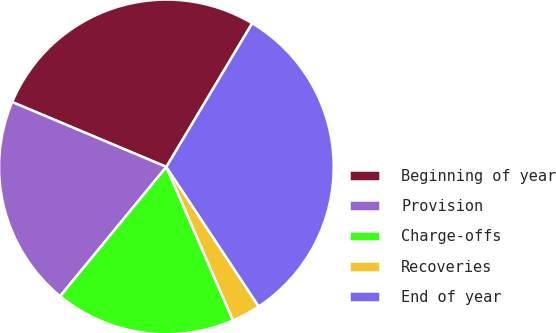Convert chart to OTSL. <chart><loc_0><loc_0><loc_500><loc_500><pie_chart><fcel>Beginning of year<fcel>Provision<fcel>Charge-offs<fcel>Recoveries<fcel>End of year<nl><fcel>27.23%<fcel>20.39%<fcel>17.46%<fcel>2.79%<fcel>32.12%<nl></chart> 